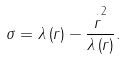Convert formula to latex. <formula><loc_0><loc_0><loc_500><loc_500>\sigma = \lambda \left ( r \right ) - \frac { \overset { \cdot } { r } ^ { 2 } } { \lambda \left ( r \right ) } .</formula> 